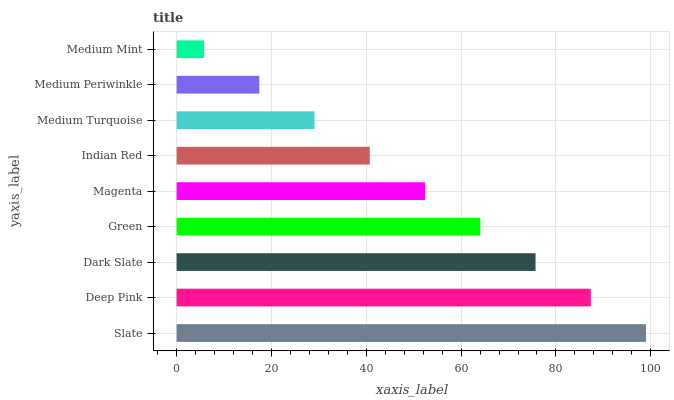Is Medium Mint the minimum?
Answer yes or no. Yes. Is Slate the maximum?
Answer yes or no. Yes. Is Deep Pink the minimum?
Answer yes or no. No. Is Deep Pink the maximum?
Answer yes or no. No. Is Slate greater than Deep Pink?
Answer yes or no. Yes. Is Deep Pink less than Slate?
Answer yes or no. Yes. Is Deep Pink greater than Slate?
Answer yes or no. No. Is Slate less than Deep Pink?
Answer yes or no. No. Is Magenta the high median?
Answer yes or no. Yes. Is Magenta the low median?
Answer yes or no. Yes. Is Medium Periwinkle the high median?
Answer yes or no. No. Is Medium Periwinkle the low median?
Answer yes or no. No. 